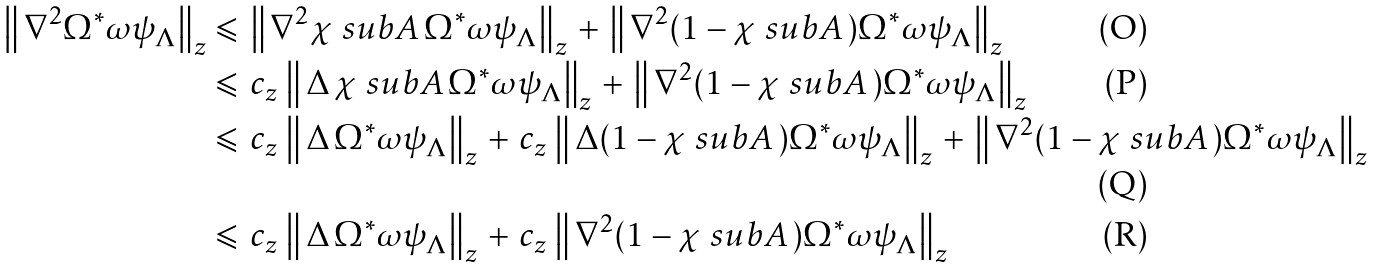Convert formula to latex. <formula><loc_0><loc_0><loc_500><loc_500>\left \| \, \nabla ^ { 2 } \Omega ^ { * } \omega \psi _ { \Lambda } \right \| _ { z } & \leqslant \, \left \| \, \nabla ^ { 2 } \chi \ s u b A \, \Omega ^ { * } \omega \psi _ { \Lambda } \right \| _ { z } \, + \, \left \| \, \nabla ^ { 2 } ( 1 - \chi \ s u b A \, ) \Omega ^ { * } \omega \psi _ { \Lambda } \right \| _ { z } \\ & \leqslant \, c _ { z } \, \left \| \, \Delta \, \chi \ s u b A \, \Omega ^ { * } \omega \psi _ { \Lambda } \right \| _ { z } \, + \, \left \| \, \nabla ^ { 2 } ( 1 - \chi \ s u b A \, ) \Omega ^ { * } \omega \psi _ { \Lambda } \right \| _ { z } \\ & \leqslant \, c _ { z } \, \left \| \, \Delta \, \Omega ^ { * } \omega \psi _ { \Lambda } \right \| _ { z } \, + \, c _ { z } \, \left \| \, \Delta ( 1 - \chi \ s u b A \, ) \Omega ^ { * } \omega \psi _ { \Lambda } \right \| _ { z } \, + \, \left \| \, \nabla ^ { 2 } ( 1 - \chi \ s u b A \, ) \Omega ^ { * } \omega \psi _ { \Lambda } \right \| _ { z } \\ & \leqslant \, c _ { z } \, \left \| \, \Delta \, \Omega ^ { * } \omega \psi _ { \Lambda } \right \| _ { z } \, + \, c _ { z } \, \left \| \, \nabla ^ { 2 } ( 1 - \chi \ s u b A \, ) \Omega ^ { * } \omega \psi _ { \Lambda } \right \| _ { z }</formula> 